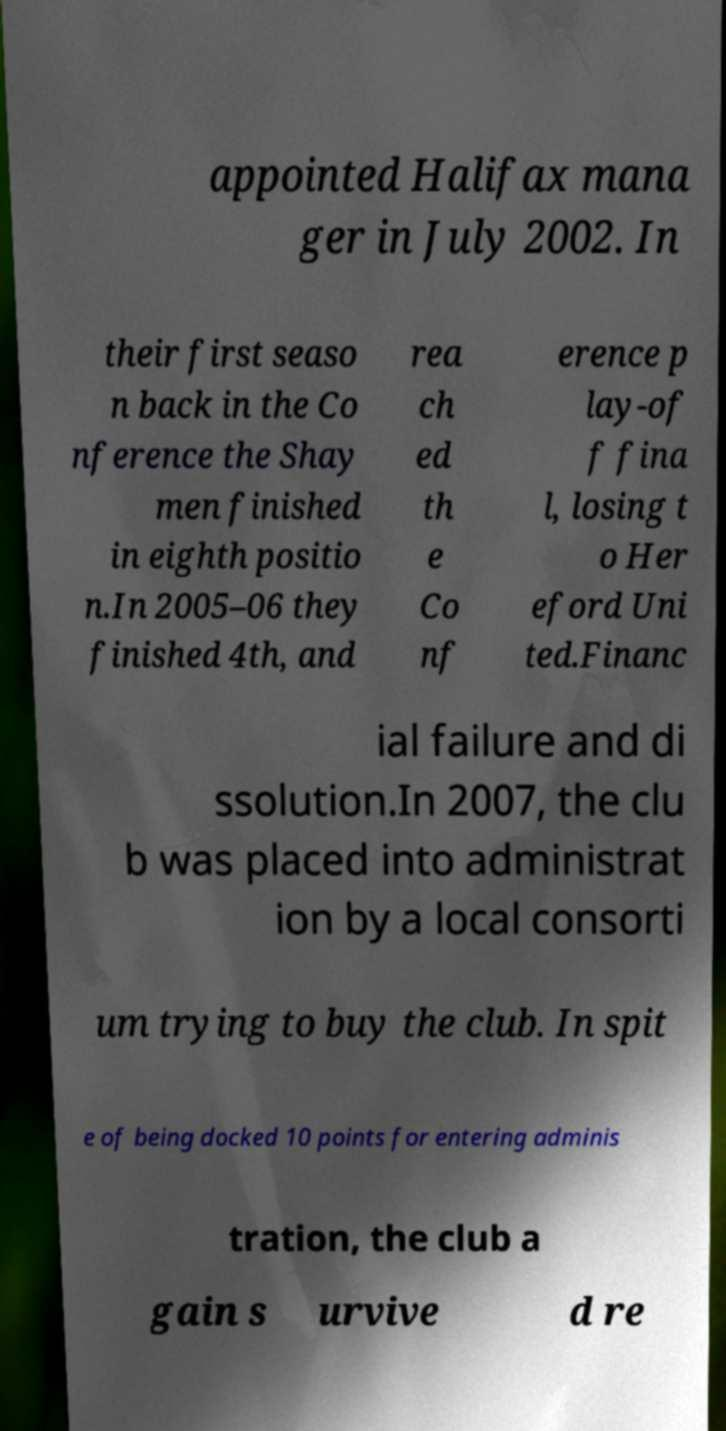For documentation purposes, I need the text within this image transcribed. Could you provide that? appointed Halifax mana ger in July 2002. In their first seaso n back in the Co nference the Shay men finished in eighth positio n.In 2005–06 they finished 4th, and rea ch ed th e Co nf erence p lay-of f fina l, losing t o Her eford Uni ted.Financ ial failure and di ssolution.In 2007, the clu b was placed into administrat ion by a local consorti um trying to buy the club. In spit e of being docked 10 points for entering adminis tration, the club a gain s urvive d re 